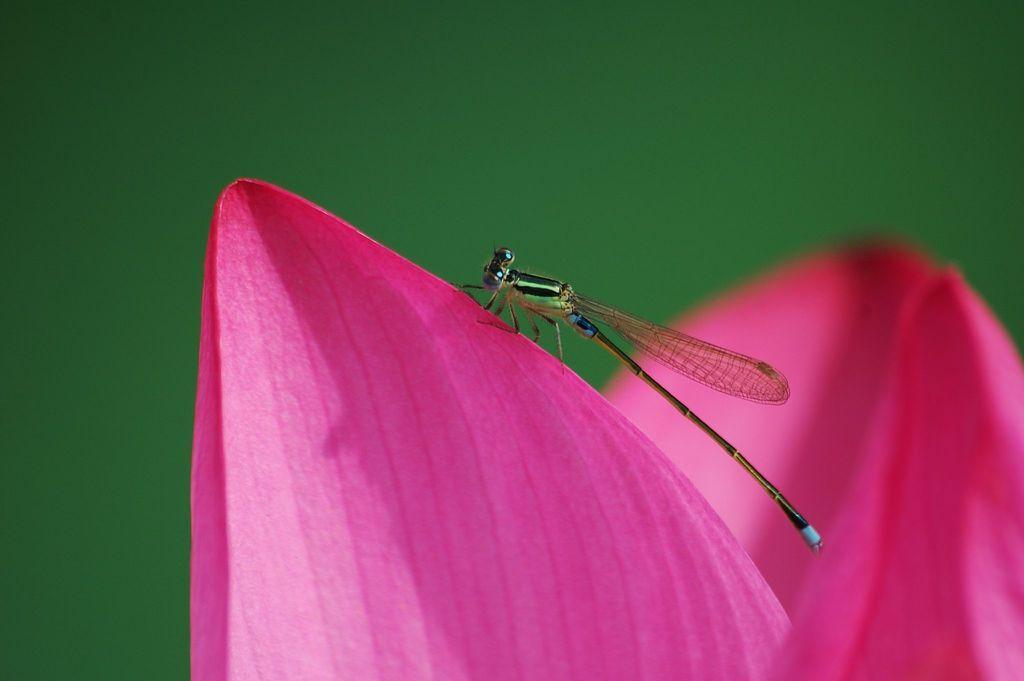How would you summarize this image in a sentence or two? In this image we can see a dragon fly sitting on a pink flower, and background is green in color. 